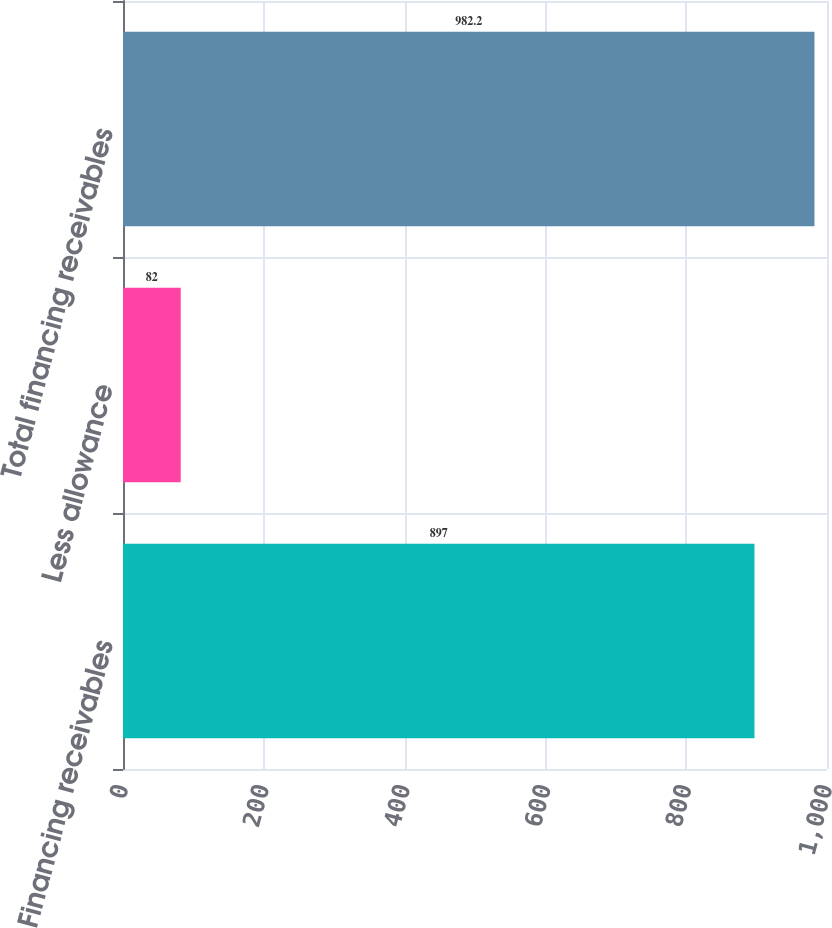<chart> <loc_0><loc_0><loc_500><loc_500><bar_chart><fcel>Financing receivables<fcel>Less allowance<fcel>Total financing receivables<nl><fcel>897<fcel>82<fcel>982.2<nl></chart> 